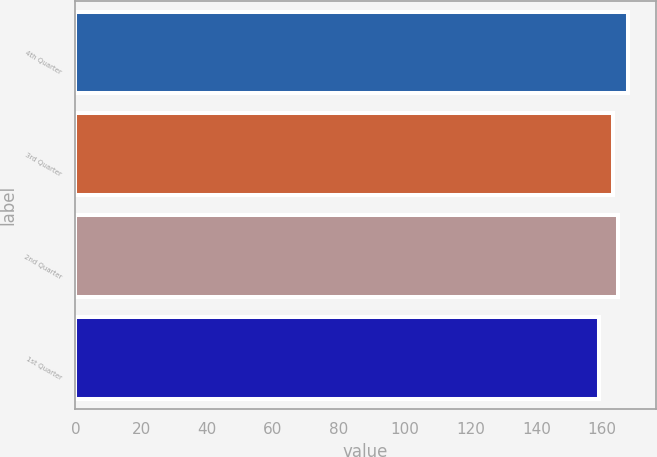Convert chart to OTSL. <chart><loc_0><loc_0><loc_500><loc_500><bar_chart><fcel>4th Quarter<fcel>3rd Quarter<fcel>2nd Quarter<fcel>1st Quarter<nl><fcel>167.91<fcel>163.33<fcel>164.77<fcel>158.89<nl></chart> 